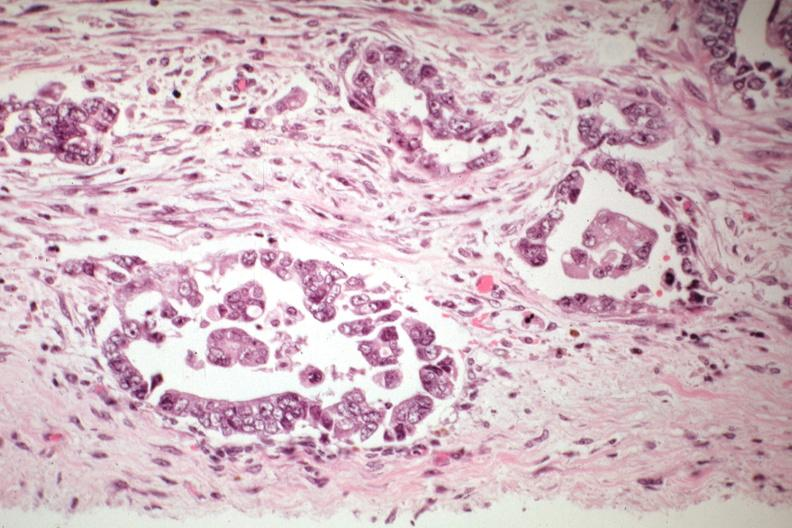what is present?
Answer the question using a single word or phrase. Mixed mesodermal tumor 